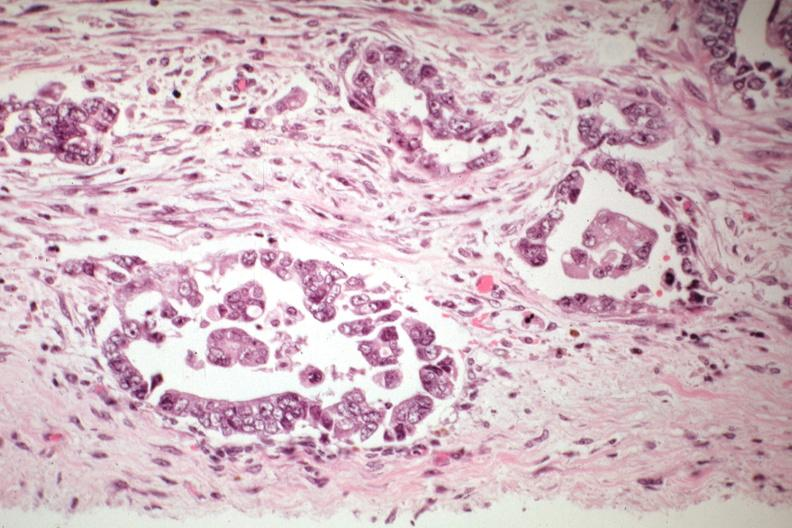what is present?
Answer the question using a single word or phrase. Mixed mesodermal tumor 